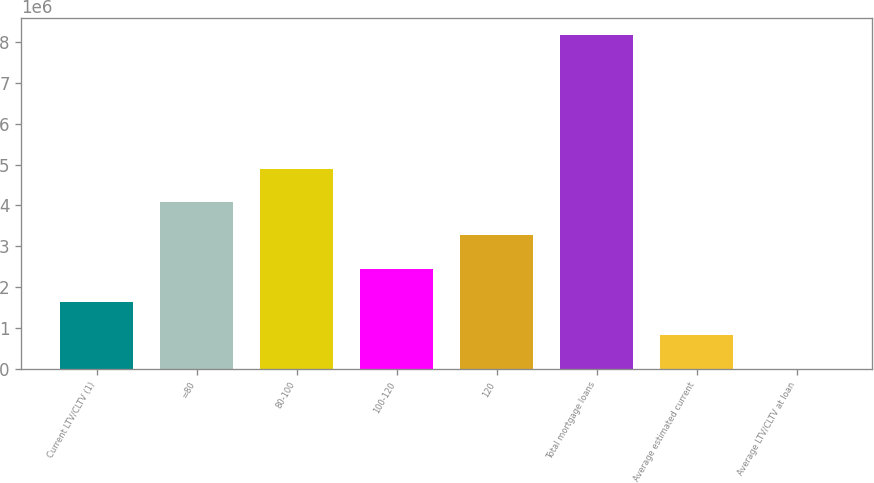<chart> <loc_0><loc_0><loc_500><loc_500><bar_chart><fcel>Current LTV/CLTV (1)<fcel>=80<fcel>80-100<fcel>100-120<fcel>120<fcel>Total mortgage loans<fcel>Average estimated current<fcel>Average LTV/CLTV at loan<nl><fcel>1.63412e+06<fcel>4.0852e+06<fcel>4.90223e+06<fcel>2.45115e+06<fcel>3.26817e+06<fcel>8.17033e+06<fcel>817096<fcel>70.6<nl></chart> 